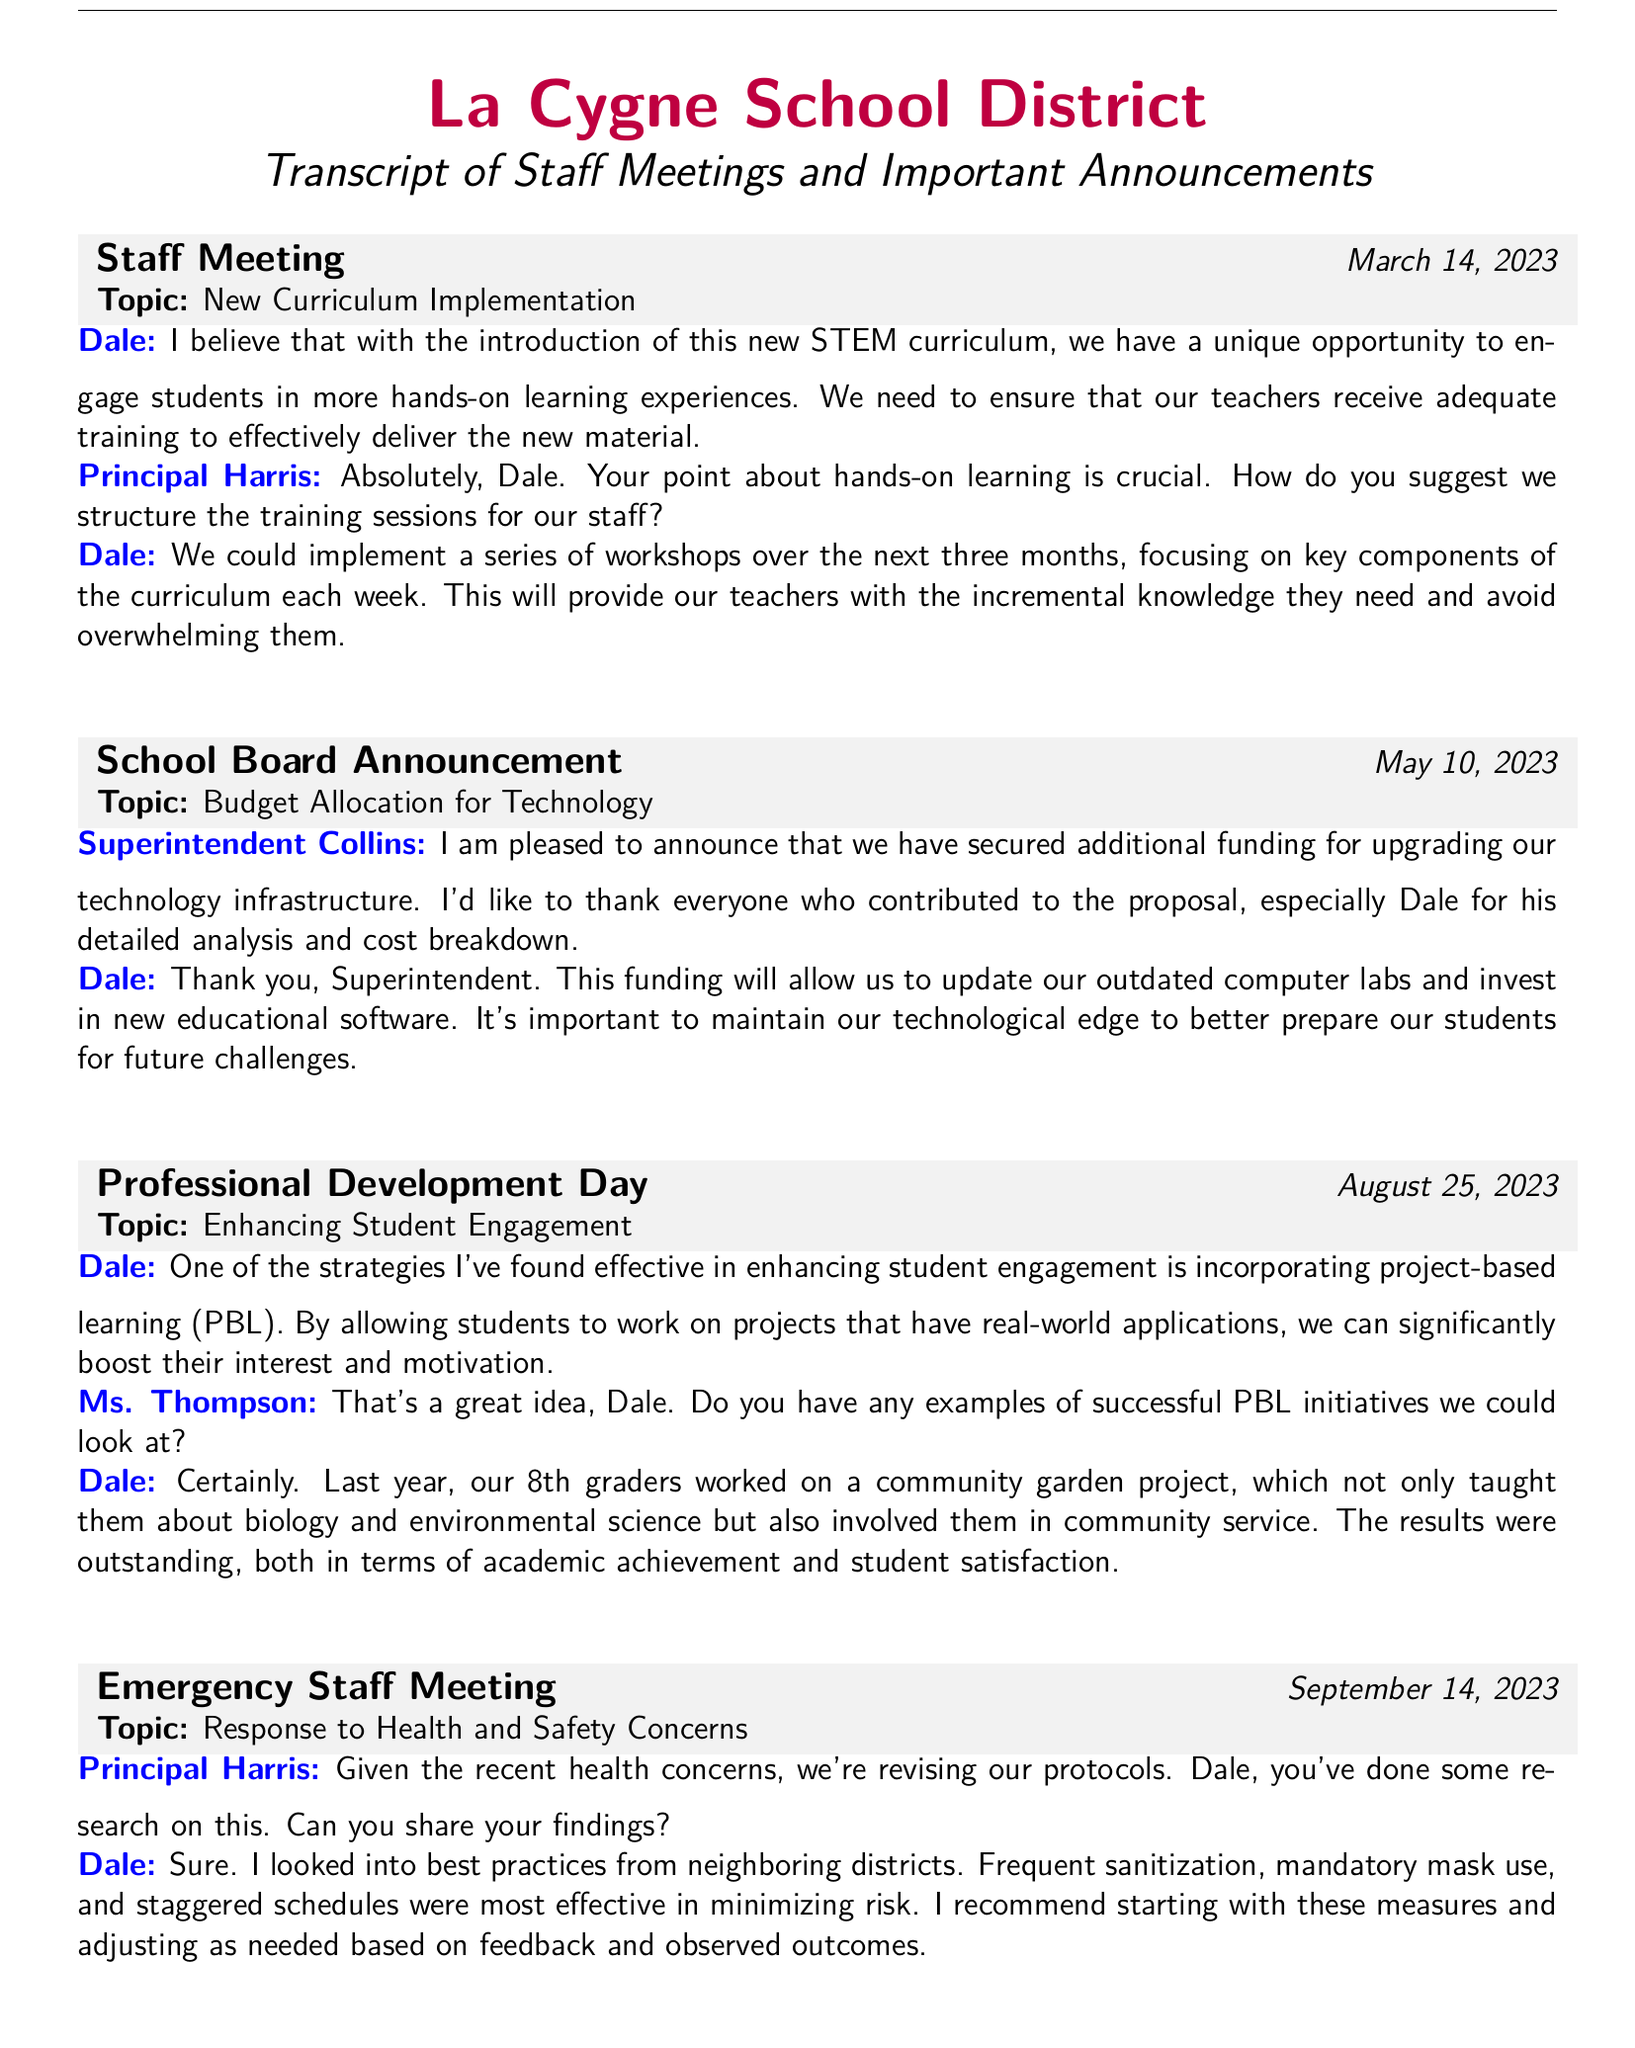What was the date of the staff meeting on new curriculum implementation? The date can be found in the meeting entry heading for the staff meeting, which is March 14, 2023.
Answer: March 14, 2023 Who contributed the idea of workshops for training sessions? The idea for workshops was suggested by Dale during the staff meeting discussion, as noted in his contribution.
Answer: Dale What is the topic discussed in the School Board Announcement on May 10, 2023? The topic of discussion is budget allocation for technology, as indicated in the meeting entry heading.
Answer: Budget Allocation for Technology Which project was mentioned by Dale as an example of project-based learning? Dale referenced the community garden project as a successful initiative in student engagement, mentioned in his contributions during the Professional Development Day.
Answer: Community garden project What recommendation did Dale make during the emergency staff meeting regarding health and safety? Dale recommended implementing frequent sanitization, mandatory mask use, and staggered schedules based on his research.
Answer: Frequent sanitization, mandatory mask use, staggered schedules What position does Superintendent Collins hold? Superintendent Collins is identified as the superintendent in the context of the School Board Announcement.
Answer: Superintendent What strategy did Dale find effective in enhancing student engagement? The effective strategy mentioned by Dale is incorporating project-based learning (PBL), as stated in his contribution during the Professional Development Day.
Answer: Project-based learning How did Dale feel about the new STEM curriculum implementation? Dale expressed a positive belief about the new curriculum and emphasized the need for teacher training in his comment.
Answer: Positive belief What was the overarching theme of the emergency staff meeting held on September 14, 2023? The theme focused on responding to health and safety concerns, as indicated in the meeting entry heading.
Answer: Health and safety concerns 